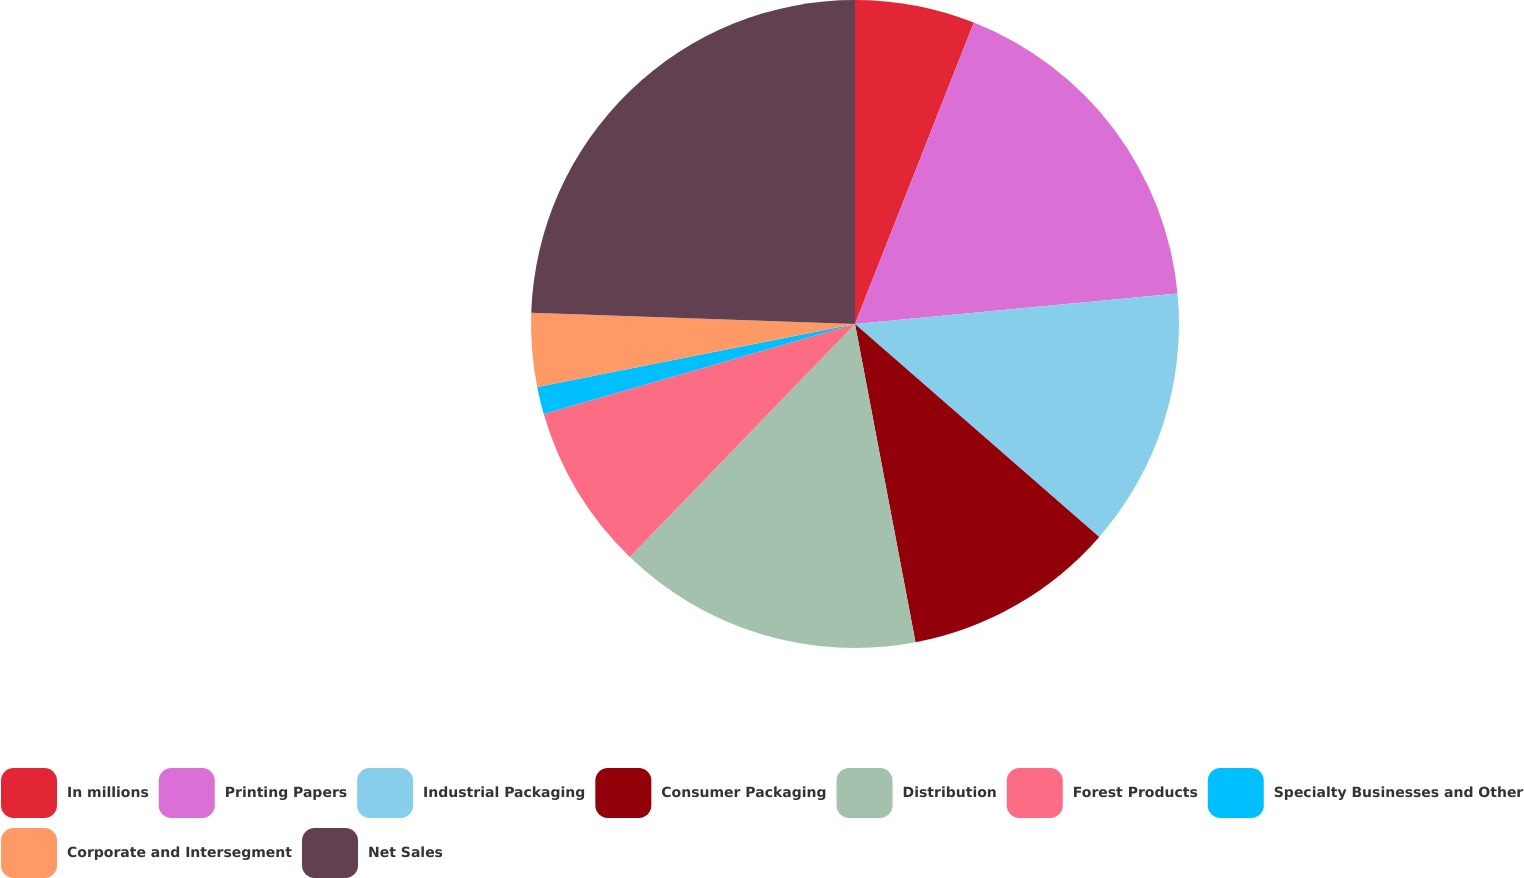Convert chart. <chart><loc_0><loc_0><loc_500><loc_500><pie_chart><fcel>In millions<fcel>Printing Papers<fcel>Industrial Packaging<fcel>Consumer Packaging<fcel>Distribution<fcel>Forest Products<fcel>Specialty Businesses and Other<fcel>Corporate and Intersegment<fcel>Net Sales<nl><fcel>5.98%<fcel>17.52%<fcel>12.91%<fcel>10.6%<fcel>15.22%<fcel>8.29%<fcel>1.36%<fcel>3.67%<fcel>24.45%<nl></chart> 